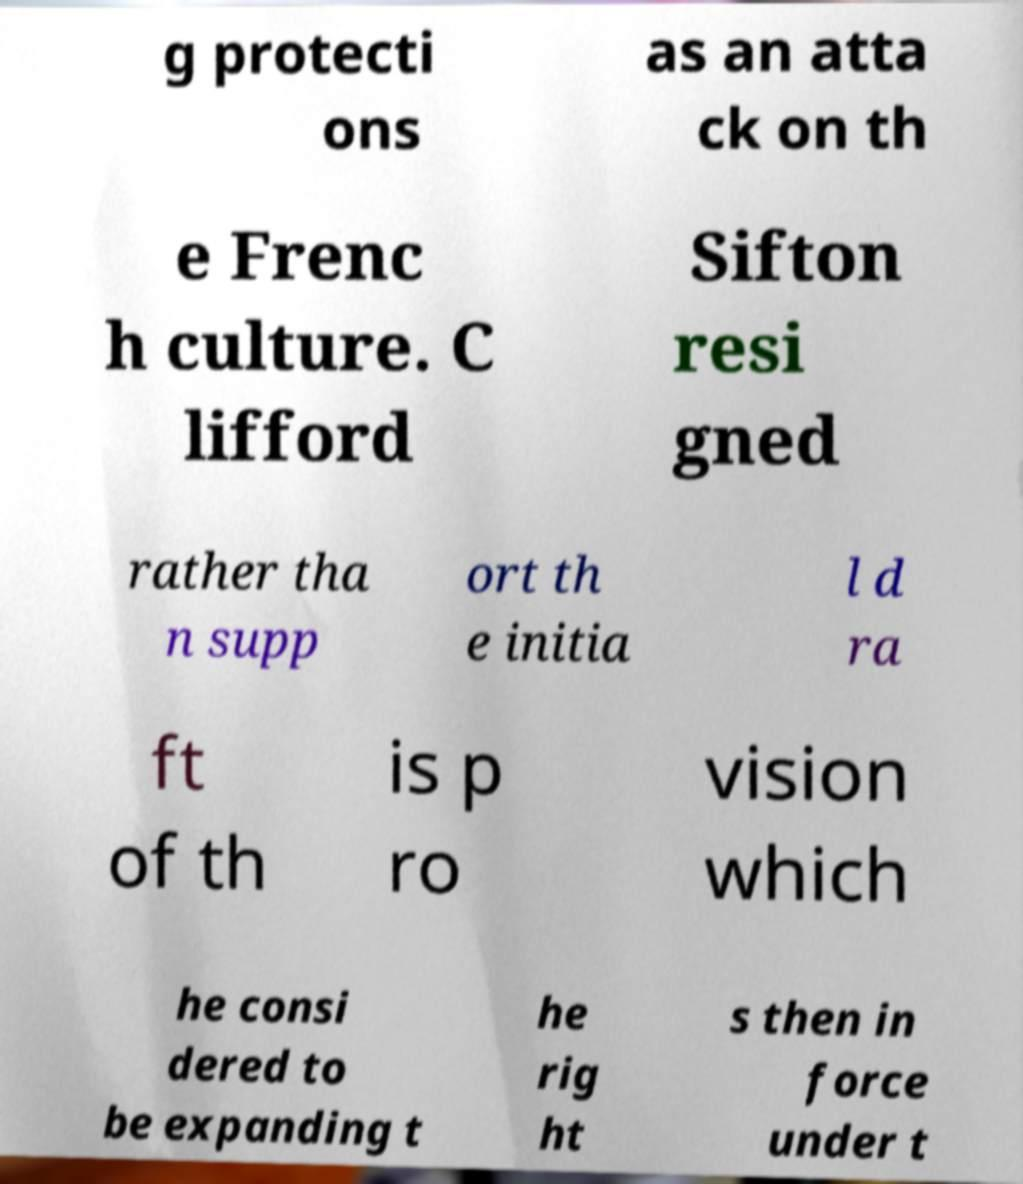There's text embedded in this image that I need extracted. Can you transcribe it verbatim? g protecti ons as an atta ck on th e Frenc h culture. C lifford Sifton resi gned rather tha n supp ort th e initia l d ra ft of th is p ro vision which he consi dered to be expanding t he rig ht s then in force under t 